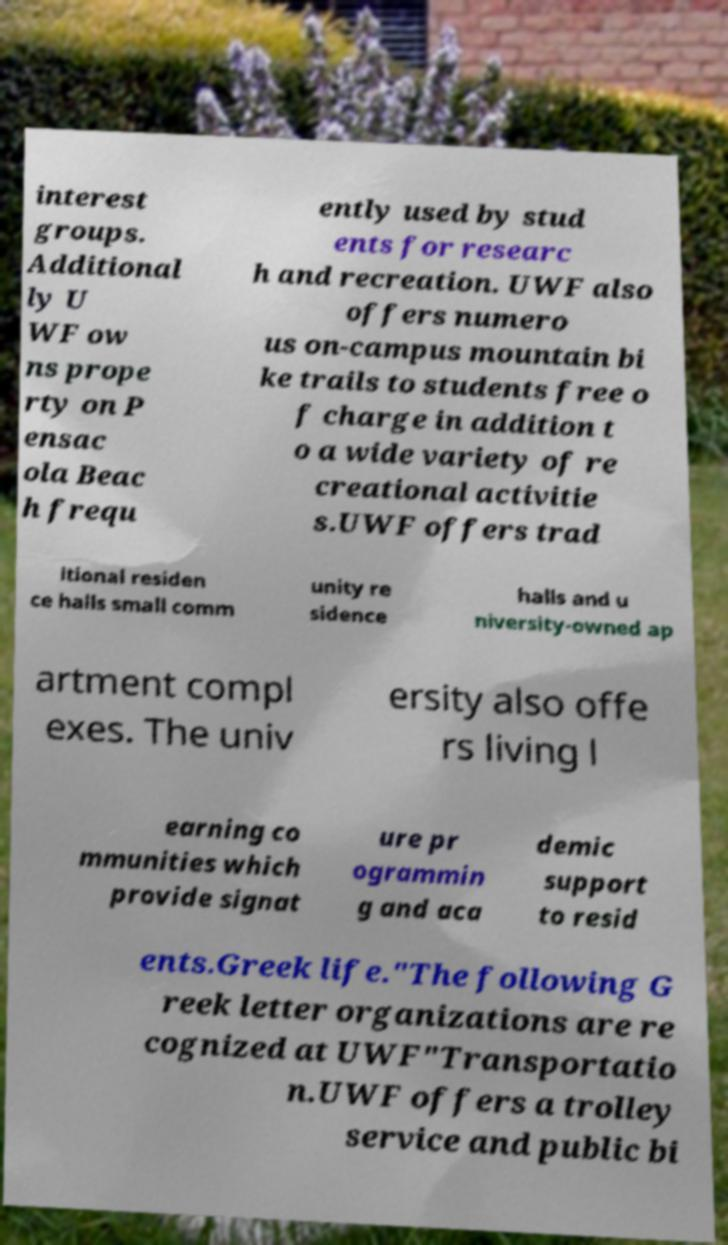For documentation purposes, I need the text within this image transcribed. Could you provide that? interest groups. Additional ly U WF ow ns prope rty on P ensac ola Beac h frequ ently used by stud ents for researc h and recreation. UWF also offers numero us on-campus mountain bi ke trails to students free o f charge in addition t o a wide variety of re creational activitie s.UWF offers trad itional residen ce halls small comm unity re sidence halls and u niversity-owned ap artment compl exes. The univ ersity also offe rs living l earning co mmunities which provide signat ure pr ogrammin g and aca demic support to resid ents.Greek life."The following G reek letter organizations are re cognized at UWF"Transportatio n.UWF offers a trolley service and public bi 